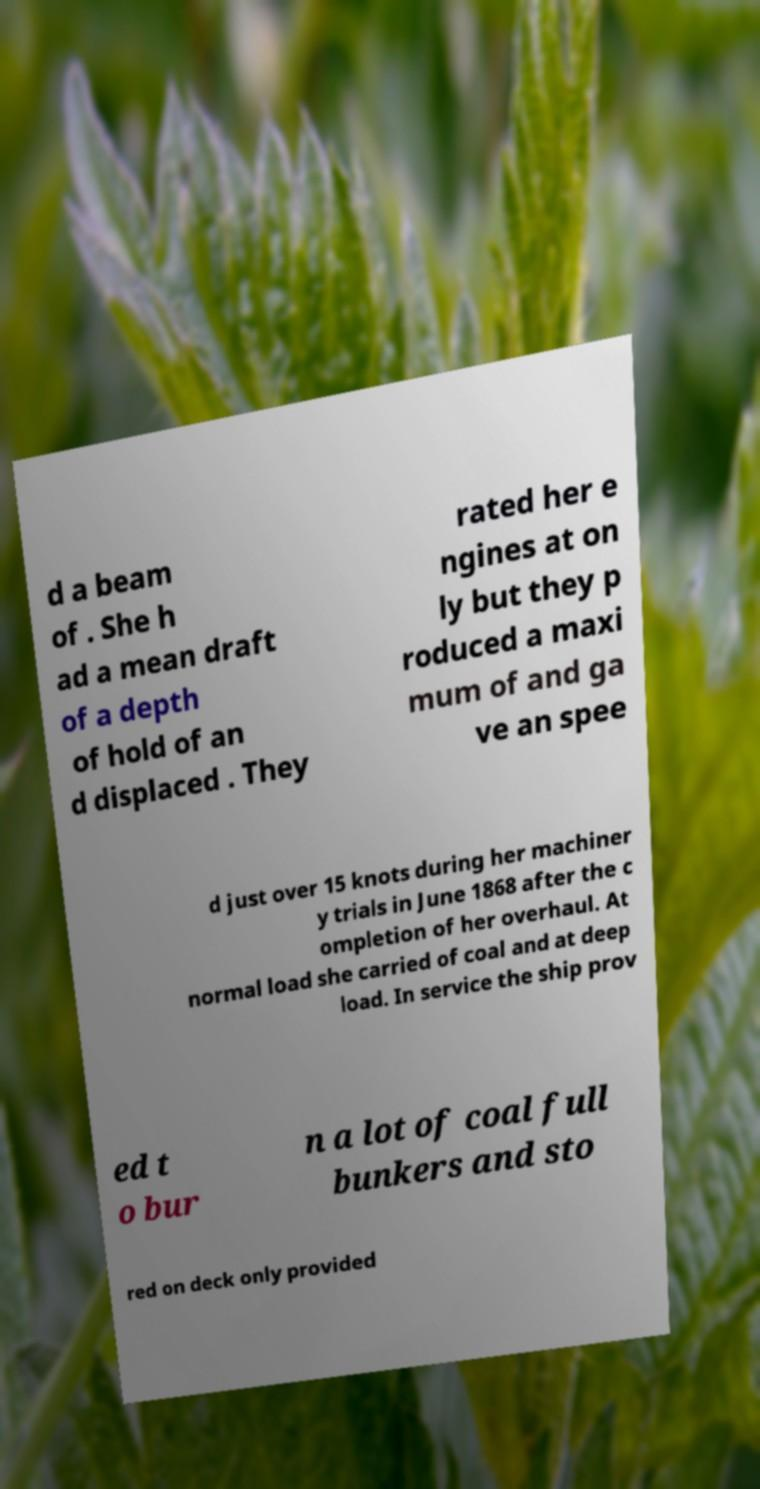What messages or text are displayed in this image? I need them in a readable, typed format. d a beam of . She h ad a mean draft of a depth of hold of an d displaced . They rated her e ngines at on ly but they p roduced a maxi mum of and ga ve an spee d just over 15 knots during her machiner y trials in June 1868 after the c ompletion of her overhaul. At normal load she carried of coal and at deep load. In service the ship prov ed t o bur n a lot of coal full bunkers and sto red on deck only provided 